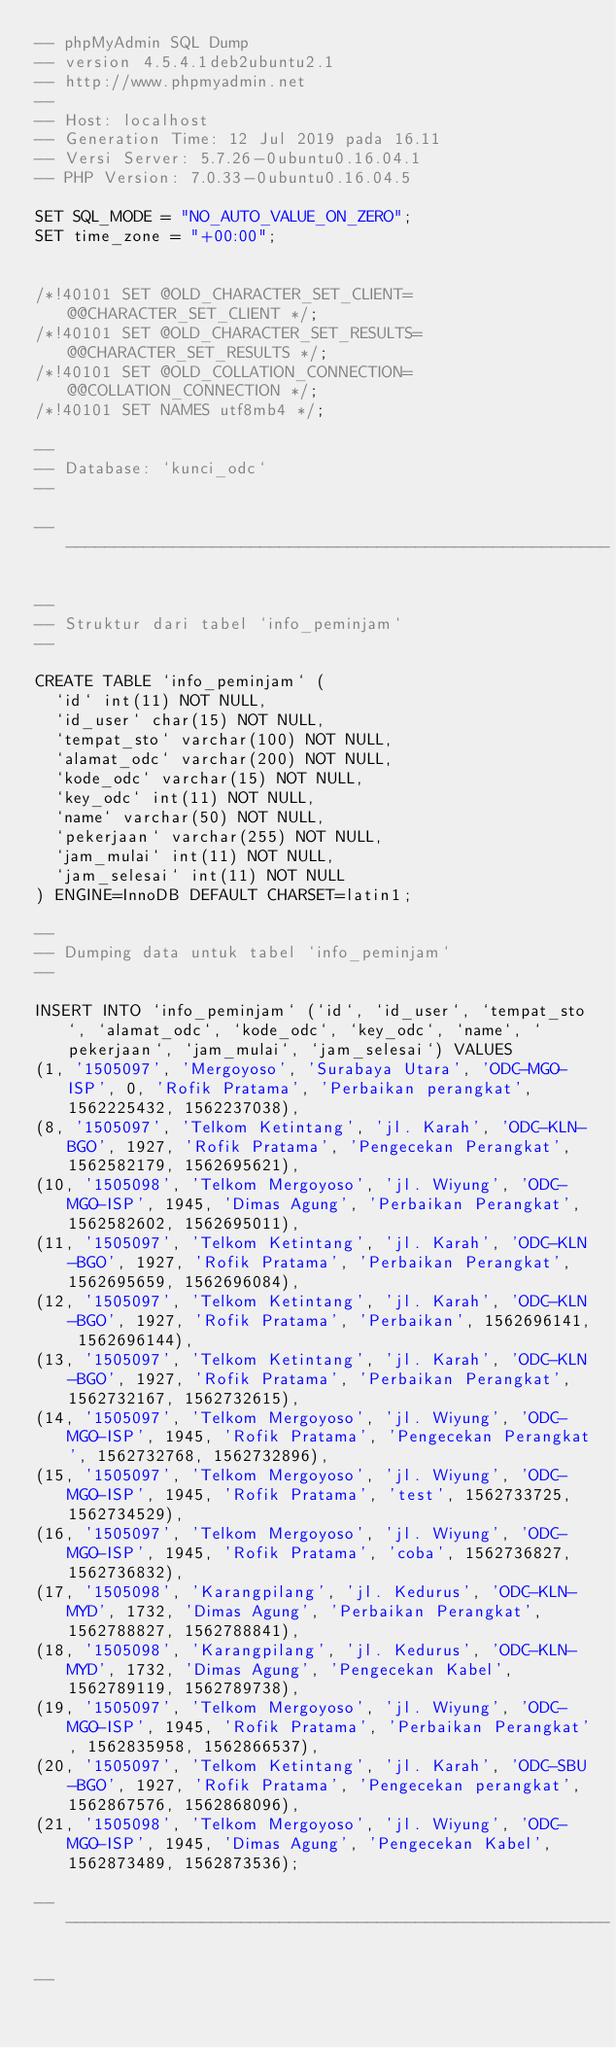<code> <loc_0><loc_0><loc_500><loc_500><_SQL_>-- phpMyAdmin SQL Dump
-- version 4.5.4.1deb2ubuntu2.1
-- http://www.phpmyadmin.net
--
-- Host: localhost
-- Generation Time: 12 Jul 2019 pada 16.11
-- Versi Server: 5.7.26-0ubuntu0.16.04.1
-- PHP Version: 7.0.33-0ubuntu0.16.04.5

SET SQL_MODE = "NO_AUTO_VALUE_ON_ZERO";
SET time_zone = "+00:00";


/*!40101 SET @OLD_CHARACTER_SET_CLIENT=@@CHARACTER_SET_CLIENT */;
/*!40101 SET @OLD_CHARACTER_SET_RESULTS=@@CHARACTER_SET_RESULTS */;
/*!40101 SET @OLD_COLLATION_CONNECTION=@@COLLATION_CONNECTION */;
/*!40101 SET NAMES utf8mb4 */;

--
-- Database: `kunci_odc`
--

-- --------------------------------------------------------

--
-- Struktur dari tabel `info_peminjam`
--

CREATE TABLE `info_peminjam` (
  `id` int(11) NOT NULL,
  `id_user` char(15) NOT NULL,
  `tempat_sto` varchar(100) NOT NULL,
  `alamat_odc` varchar(200) NOT NULL,
  `kode_odc` varchar(15) NOT NULL,
  `key_odc` int(11) NOT NULL,
  `name` varchar(50) NOT NULL,
  `pekerjaan` varchar(255) NOT NULL,
  `jam_mulai` int(11) NOT NULL,
  `jam_selesai` int(11) NOT NULL
) ENGINE=InnoDB DEFAULT CHARSET=latin1;

--
-- Dumping data untuk tabel `info_peminjam`
--

INSERT INTO `info_peminjam` (`id`, `id_user`, `tempat_sto`, `alamat_odc`, `kode_odc`, `key_odc`, `name`, `pekerjaan`, `jam_mulai`, `jam_selesai`) VALUES
(1, '1505097', 'Mergoyoso', 'Surabaya Utara', 'ODC-MGO-ISP', 0, 'Rofik Pratama', 'Perbaikan perangkat', 1562225432, 1562237038),
(8, '1505097', 'Telkom Ketintang', 'jl. Karah', 'ODC-KLN-BGO', 1927, 'Rofik Pratama', 'Pengecekan Perangkat', 1562582179, 1562695621),
(10, '1505098', 'Telkom Mergoyoso', 'jl. Wiyung', 'ODC-MGO-ISP', 1945, 'Dimas Agung', 'Perbaikan Perangkat', 1562582602, 1562695011),
(11, '1505097', 'Telkom Ketintang', 'jl. Karah', 'ODC-KLN-BGO', 1927, 'Rofik Pratama', 'Perbaikan Perangkat', 1562695659, 1562696084),
(12, '1505097', 'Telkom Ketintang', 'jl. Karah', 'ODC-KLN-BGO', 1927, 'Rofik Pratama', 'Perbaikan', 1562696141, 1562696144),
(13, '1505097', 'Telkom Ketintang', 'jl. Karah', 'ODC-KLN-BGO', 1927, 'Rofik Pratama', 'Perbaikan Perangkat', 1562732167, 1562732615),
(14, '1505097', 'Telkom Mergoyoso', 'jl. Wiyung', 'ODC-MGO-ISP', 1945, 'Rofik Pratama', 'Pengecekan Perangkat', 1562732768, 1562732896),
(15, '1505097', 'Telkom Mergoyoso', 'jl. Wiyung', 'ODC-MGO-ISP', 1945, 'Rofik Pratama', 'test', 1562733725, 1562734529),
(16, '1505097', 'Telkom Mergoyoso', 'jl. Wiyung', 'ODC-MGO-ISP', 1945, 'Rofik Pratama', 'coba', 1562736827, 1562736832),
(17, '1505098', 'Karangpilang', 'jl. Kedurus', 'ODC-KLN-MYD', 1732, 'Dimas Agung', 'Perbaikan Perangkat', 1562788827, 1562788841),
(18, '1505098', 'Karangpilang', 'jl. Kedurus', 'ODC-KLN-MYD', 1732, 'Dimas Agung', 'Pengecekan Kabel', 1562789119, 1562789738),
(19, '1505097', 'Telkom Mergoyoso', 'jl. Wiyung', 'ODC-MGO-ISP', 1945, 'Rofik Pratama', 'Perbaikan Perangkat', 1562835958, 1562866537),
(20, '1505097', 'Telkom Ketintang', 'jl. Karah', 'ODC-SBU-BGO', 1927, 'Rofik Pratama', 'Pengecekan perangkat', 1562867576, 1562868096),
(21, '1505098', 'Telkom Mergoyoso', 'jl. Wiyung', 'ODC-MGO-ISP', 1945, 'Dimas Agung', 'Pengecekan Kabel', 1562873489, 1562873536);

-- --------------------------------------------------------

--</code> 